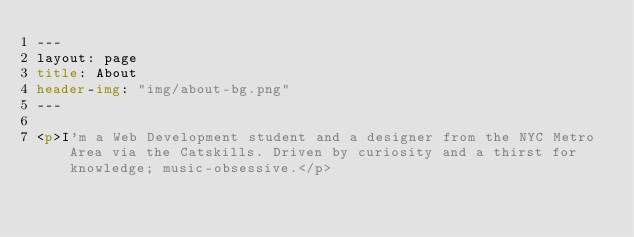<code> <loc_0><loc_0><loc_500><loc_500><_HTML_>---
layout: page
title: About
header-img: "img/about-bg.png"
---

<p>I'm a Web Development student and a designer from the NYC Metro Area via the Catskills. Driven by curiosity and a thirst for knowledge; music-obsessive.</p>
</code> 